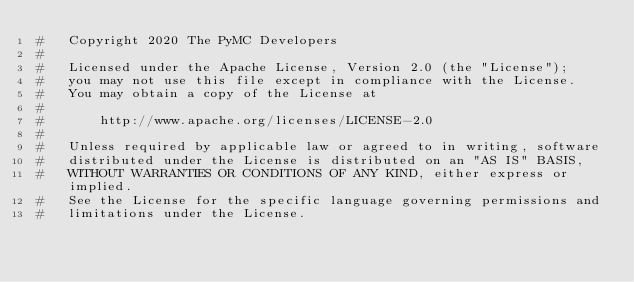Convert code to text. <code><loc_0><loc_0><loc_500><loc_500><_Python_>#   Copyright 2020 The PyMC Developers
#
#   Licensed under the Apache License, Version 2.0 (the "License");
#   you may not use this file except in compliance with the License.
#   You may obtain a copy of the License at
#
#       http://www.apache.org/licenses/LICENSE-2.0
#
#   Unless required by applicable law or agreed to in writing, software
#   distributed under the License is distributed on an "AS IS" BASIS,
#   WITHOUT WARRANTIES OR CONDITIONS OF ANY KIND, either express or implied.
#   See the License for the specific language governing permissions and
#   limitations under the License.
</code> 